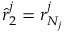<formula> <loc_0><loc_0><loc_500><loc_500>\hat { r } _ { 2 } ^ { j } = r _ { N _ { j } } ^ { j }</formula> 